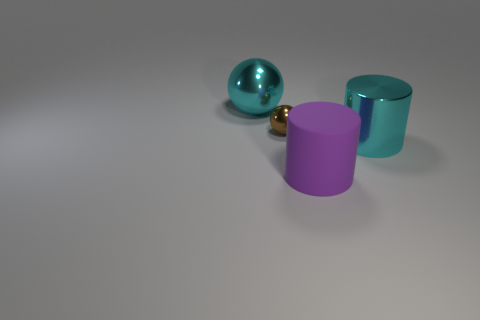Is there anything else that has the same size as the rubber thing?
Your response must be concise. Yes. What shape is the big cyan metallic thing that is on the left side of the cyan metallic object that is in front of the tiny shiny ball?
Offer a very short reply. Sphere. Is the size of the shiny cylinder that is right of the purple thing the same as the small brown metallic ball?
Ensure brevity in your answer.  No. How many other objects are the same shape as the purple thing?
Your answer should be very brief. 1. Is the color of the big shiny thing behind the cyan metallic cylinder the same as the shiny cylinder?
Your answer should be very brief. Yes. Are there any big balls that have the same color as the big metallic cylinder?
Your answer should be compact. Yes. What number of big cyan things are in front of the brown metallic thing?
Your answer should be compact. 1. What number of other things are the same size as the cyan metal cylinder?
Your answer should be compact. 2. Are the big cyan thing that is left of the metallic cylinder and the purple object to the right of the small thing made of the same material?
Give a very brief answer. No. What is the color of the metal object that is the same size as the cyan cylinder?
Keep it short and to the point. Cyan. 